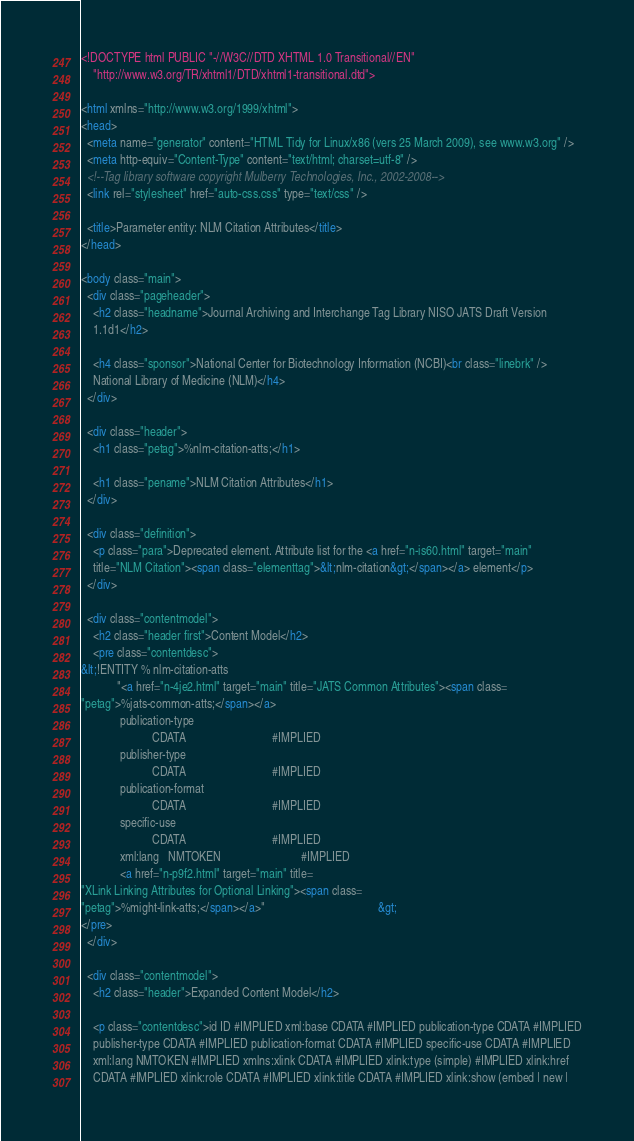<code> <loc_0><loc_0><loc_500><loc_500><_HTML_><!DOCTYPE html PUBLIC "-//W3C//DTD XHTML 1.0 Transitional//EN"
    "http://www.w3.org/TR/xhtml1/DTD/xhtml1-transitional.dtd">

<html xmlns="http://www.w3.org/1999/xhtml">
<head>
  <meta name="generator" content="HTML Tidy for Linux/x86 (vers 25 March 2009), see www.w3.org" />
  <meta http-equiv="Content-Type" content="text/html; charset=utf-8" />
  <!--Tag library software copyright Mulberry Technologies, Inc., 2002-2008-->
  <link rel="stylesheet" href="auto-css.css" type="text/css" />

  <title>Parameter entity: NLM Citation Attributes</title>
</head>

<body class="main">
  <div class="pageheader">
    <h2 class="headname">Journal Archiving and Interchange Tag Library NISO JATS Draft Version
    1.1d1</h2>

    <h4 class="sponsor">National Center for Biotechnology Information (NCBI)<br class="linebrk" />
    National Library of Medicine (NLM)</h4>
  </div>

  <div class="header">
    <h1 class="petag">%nlm-citation-atts;</h1>

    <h1 class="pename">NLM Citation Attributes</h1>
  </div>

  <div class="definition">
    <p class="para">Deprecated element. Attribute list for the <a href="n-is60.html" target="main"
    title="NLM Citation"><span class="elementtag">&lt;nlm-citation&gt;</span></a> element</p>
  </div>

  <div class="contentmodel">
    <h2 class="header first">Content Model</h2>
    <pre class="contentdesc">
&lt;!ENTITY % nlm-citation-atts
            "<a href="n-4je2.html" target="main" title="JATS Common Attributes"><span class=
"petag">%jats-common-atts;</span></a>                                       
             publication-type
                        CDATA                             #IMPLIED
             publisher-type
                        CDATA                             #IMPLIED
             publication-format
                        CDATA                             #IMPLIED
             specific-use
                        CDATA                             #IMPLIED
             xml:lang   NMTOKEN                           #IMPLIED
             <a href="n-p9f2.html" target="main" title=
"XLink Linking Attributes for Optional Linking"><span class=
"petag">%might-link-atts;</span></a>"                                      &gt;
</pre>
  </div>

  <div class="contentmodel">
    <h2 class="header">Expanded Content Model</h2>

    <p class="contentdesc">id ID #IMPLIED xml:base CDATA #IMPLIED publication-type CDATA #IMPLIED
    publisher-type CDATA #IMPLIED publication-format CDATA #IMPLIED specific-use CDATA #IMPLIED
    xml:lang NMTOKEN #IMPLIED xmlns:xlink CDATA #IMPLIED xlink:type (simple) #IMPLIED xlink:href
    CDATA #IMPLIED xlink:role CDATA #IMPLIED xlink:title CDATA #IMPLIED xlink:show (embed | new |</code> 